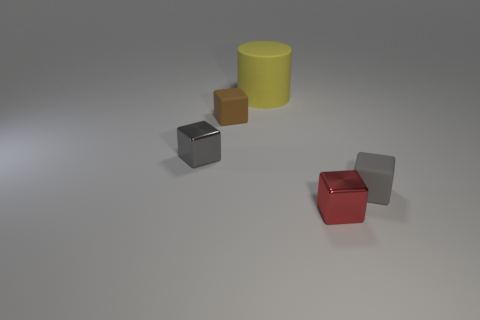There is a small matte thing to the right of the tiny brown block; is it the same color as the tiny shiny block in front of the gray metal block?
Your response must be concise. No. There is a red cube that is the same size as the brown cube; what is it made of?
Offer a terse response. Metal. There is a tiny gray thing that is in front of the small gray thing behind the tiny rubber object that is right of the red cube; what is its shape?
Make the answer very short. Cube. What shape is the red thing that is the same size as the brown object?
Provide a short and direct response. Cube. There is a small matte thing behind the matte block that is on the right side of the yellow cylinder; how many tiny brown matte blocks are in front of it?
Your answer should be very brief. 0. Is the number of gray shiny cubes that are behind the big cylinder greater than the number of yellow matte things that are in front of the red cube?
Ensure brevity in your answer.  No. How many brown objects are the same shape as the gray metal object?
Keep it short and to the point. 1. How many objects are either small matte blocks that are to the left of the yellow cylinder or small metallic cubes on the left side of the large rubber thing?
Provide a short and direct response. 2. What material is the small gray thing left of the small object in front of the matte thing on the right side of the small red thing?
Ensure brevity in your answer.  Metal. There is a metallic object on the right side of the small brown block; is its color the same as the matte cylinder?
Ensure brevity in your answer.  No. 